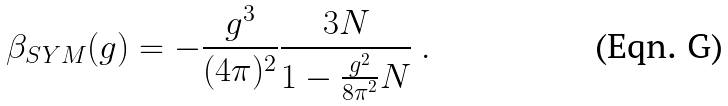Convert formula to latex. <formula><loc_0><loc_0><loc_500><loc_500>\beta _ { S Y M } ( g ) = - \frac { g ^ { 3 } } { ( 4 \pi ) ^ { 2 } } \frac { 3 N } { 1 - \frac { g ^ { 2 } } { 8 \pi ^ { 2 } } N } \ .</formula> 